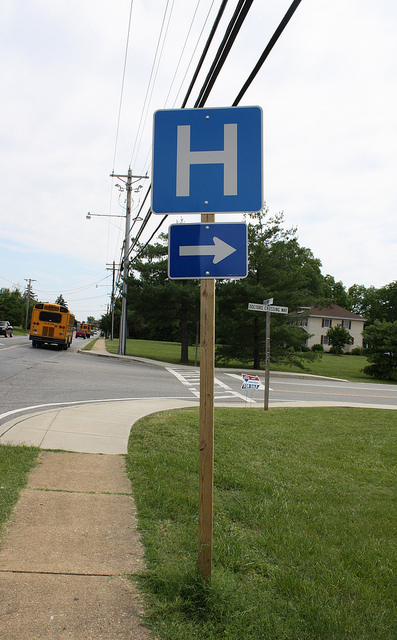<image>What kind of sign is red? I don't know what kind of sign is red, there might not be any red sign in the image. However, some say it's a stop sign. What kind of tree is across the crosswalk? I don't know what kind of tree is across the crosswalk. It could be a cedar, willow, oak, fir or maple. How many miles to Kingstown? It is unclear how many miles are to Kingstown because there is no mile sign. What kind of sign is red? There is no red sign in the image. How many miles to Kingstown? I am not sure how many miles it is to Kingstown. It could be 0, 10, 100, or 40. What kind of tree is across the crosswalk? I am not sure what kind of tree is across the crosswalk. It can be cedar, willow, oak, fir, or maple. 